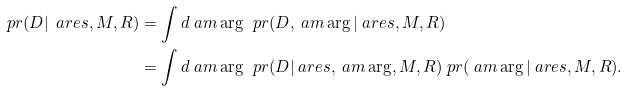<formula> <loc_0><loc_0><loc_500><loc_500>\ p r ( D | \ a r e s , M , R ) & = \int d \ a m \arg \, \ p r ( D , \ a m \arg | \ a r e s , M , R ) \\ & = \int d \ a m \arg \, \ p r ( D | \ a r e s , \ a m \arg , M , R ) \ p r ( \ a m \arg | \ a r e s , M , R ) .</formula> 